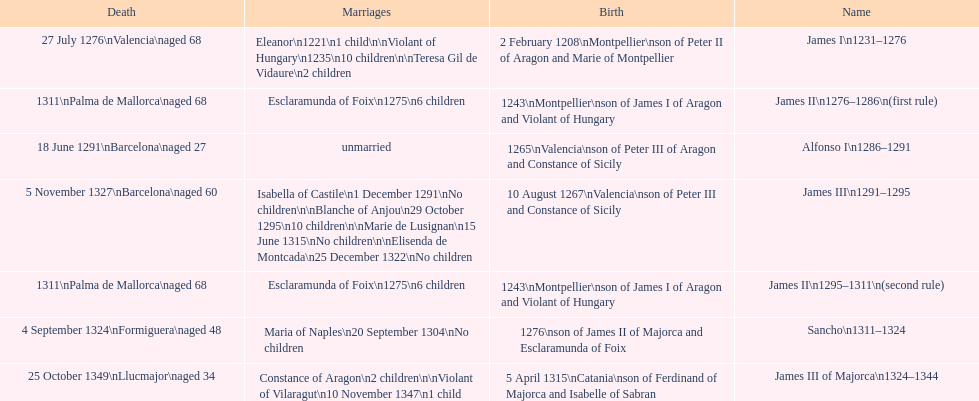Which monarch is listed first? James I 1231-1276. 